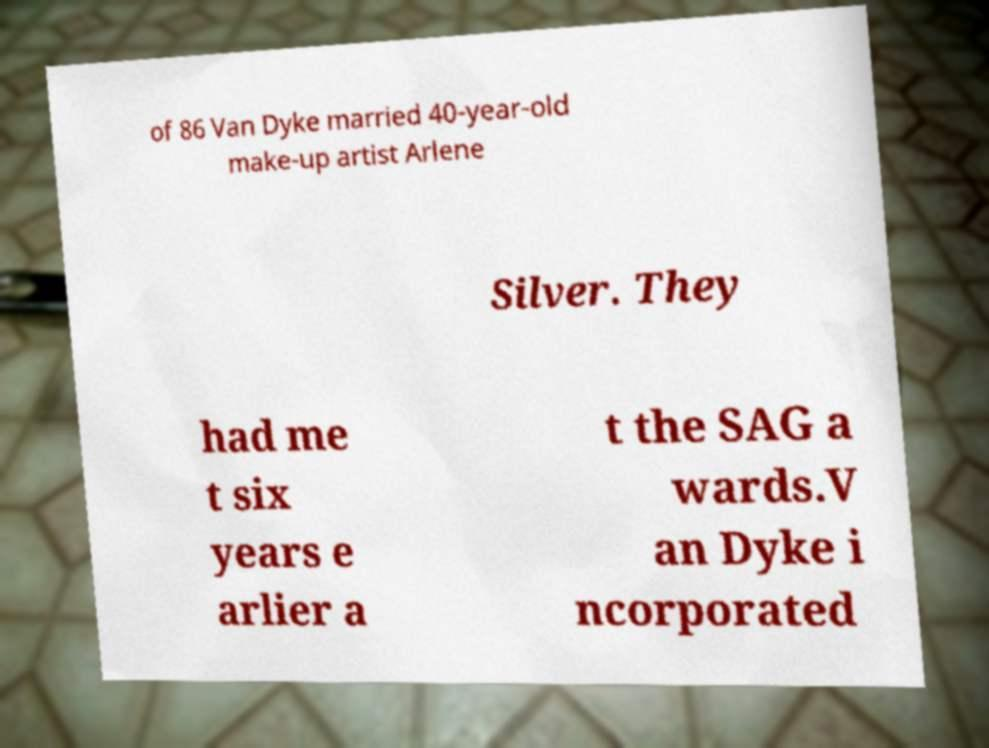Can you read and provide the text displayed in the image?This photo seems to have some interesting text. Can you extract and type it out for me? of 86 Van Dyke married 40-year-old make-up artist Arlene Silver. They had me t six years e arlier a t the SAG a wards.V an Dyke i ncorporated 